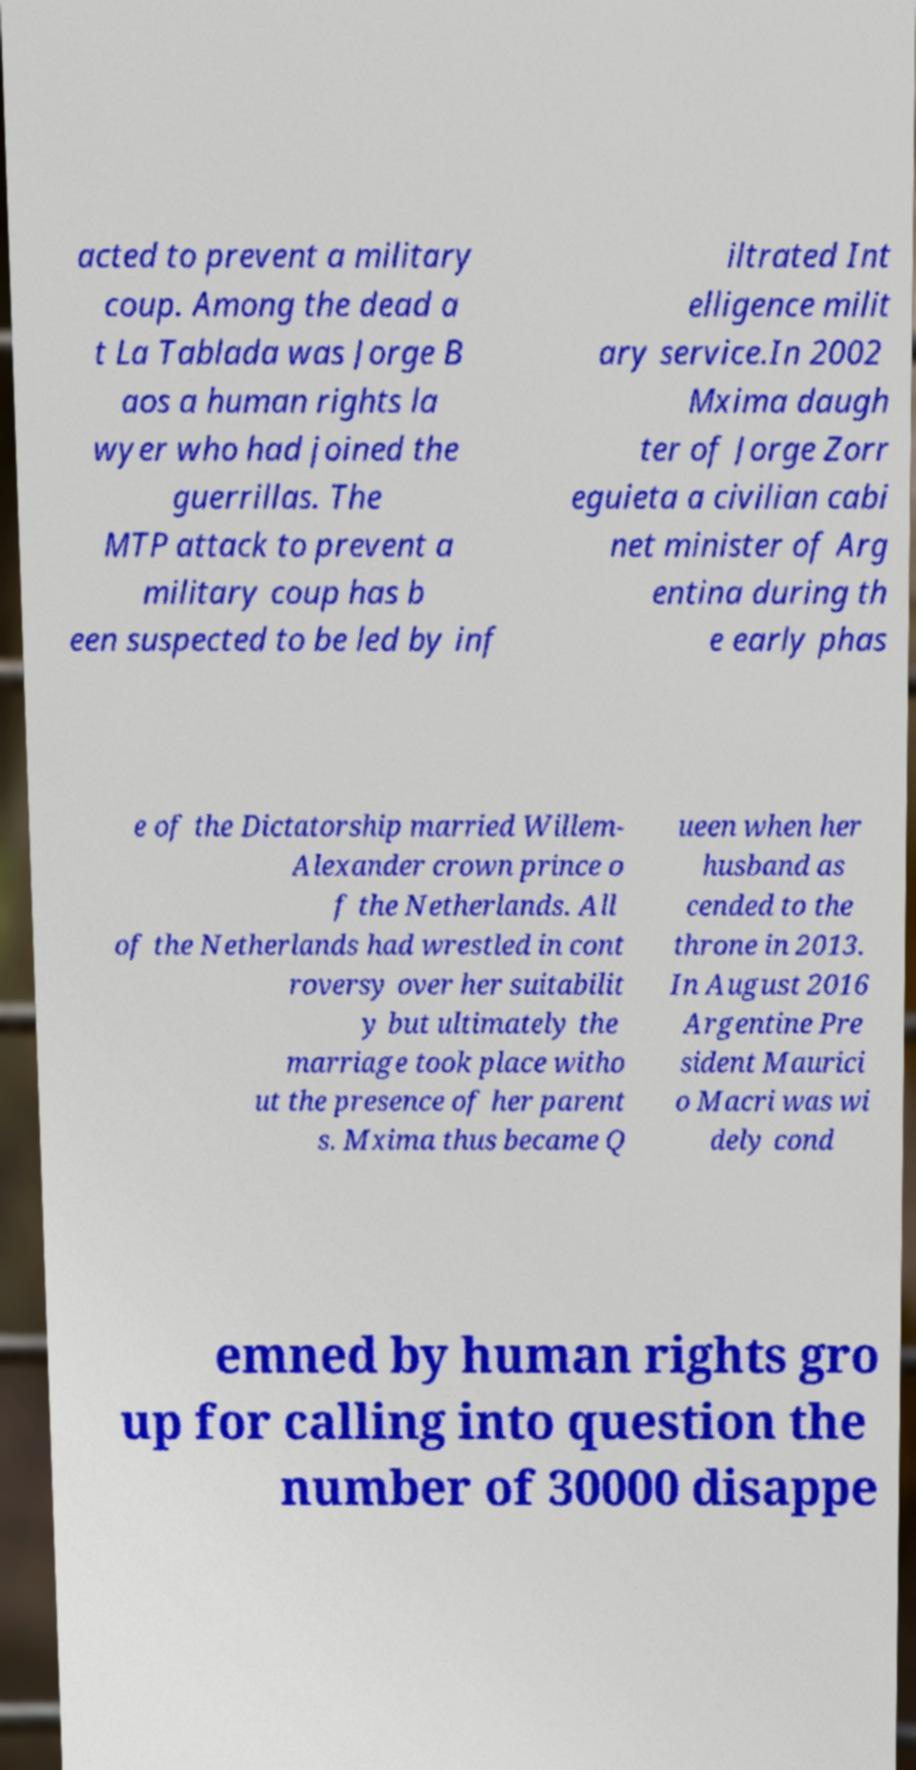There's text embedded in this image that I need extracted. Can you transcribe it verbatim? acted to prevent a military coup. Among the dead a t La Tablada was Jorge B aos a human rights la wyer who had joined the guerrillas. The MTP attack to prevent a military coup has b een suspected to be led by inf iltrated Int elligence milit ary service.In 2002 Mxima daugh ter of Jorge Zorr eguieta a civilian cabi net minister of Arg entina during th e early phas e of the Dictatorship married Willem- Alexander crown prince o f the Netherlands. All of the Netherlands had wrestled in cont roversy over her suitabilit y but ultimately the marriage took place witho ut the presence of her parent s. Mxima thus became Q ueen when her husband as cended to the throne in 2013. In August 2016 Argentine Pre sident Maurici o Macri was wi dely cond emned by human rights gro up for calling into question the number of 30000 disappe 